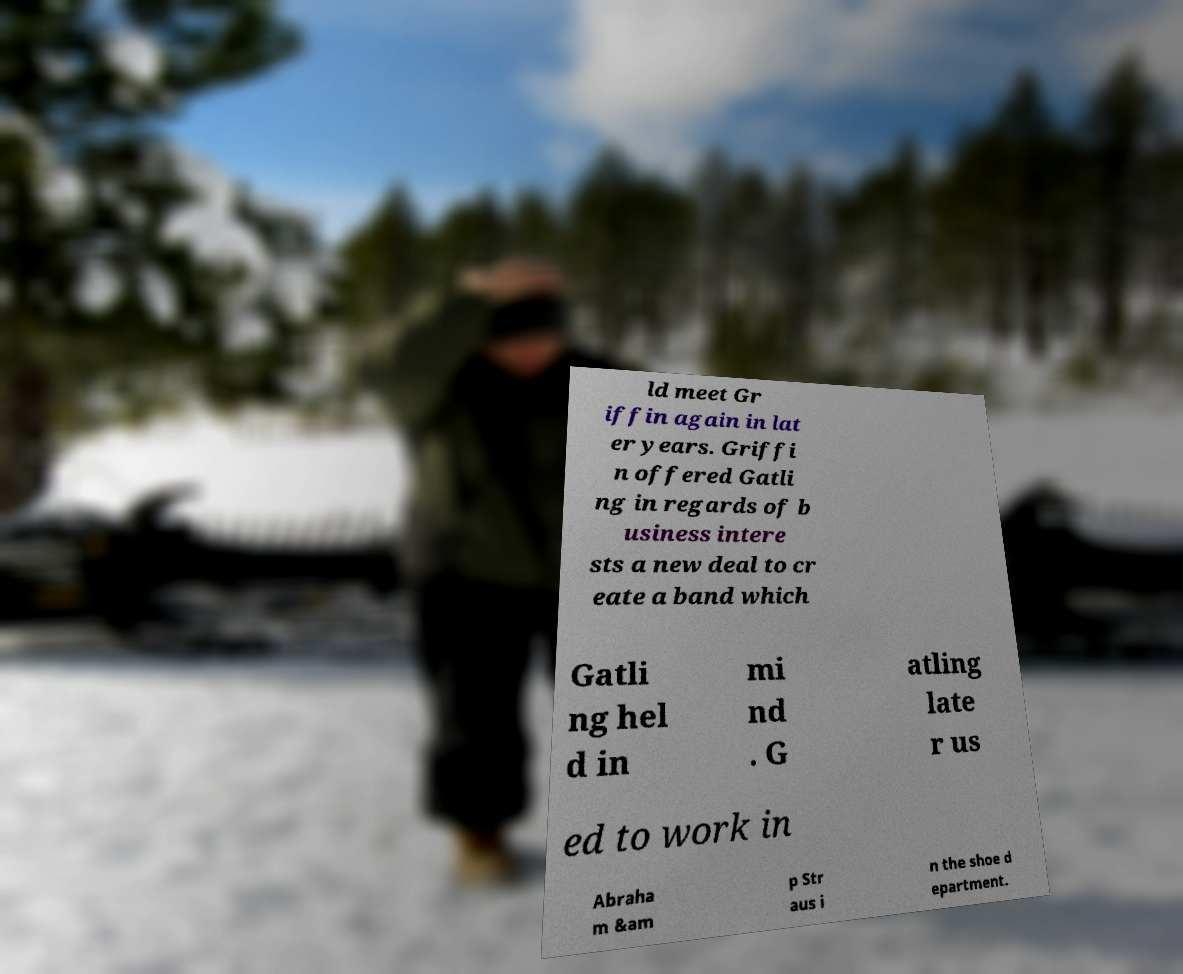What messages or text are displayed in this image? I need them in a readable, typed format. ld meet Gr iffin again in lat er years. Griffi n offered Gatli ng in regards of b usiness intere sts a new deal to cr eate a band which Gatli ng hel d in mi nd . G atling late r us ed to work in Abraha m &am p Str aus i n the shoe d epartment. 